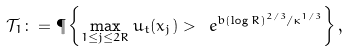Convert formula to latex. <formula><loc_0><loc_0><loc_500><loc_500>\mathcal { T } _ { 1 } \colon = \P \left \{ \max _ { 1 \leq j \leq 2 R } u _ { t } ( x _ { j } ) > \ e ^ { b ( \log R ) ^ { 2 / 3 } / \kappa ^ { 1 / 3 } } \right \} ,</formula> 